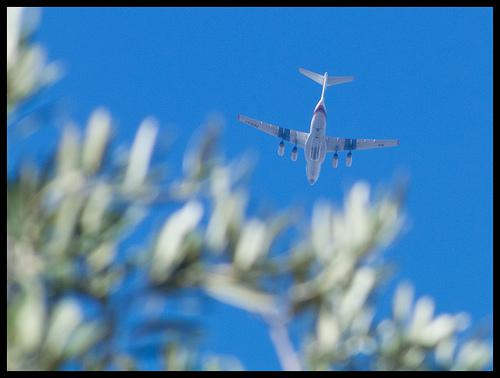Question: what is blurry?
Choices:
A. Berries.
B. Bushes.
C. Flowers.
D. Trees.
Answer with the letter. Answer: D Question: where is the plane?
Choices:
A. In the water.
B. In the sky.
C. In outer space.
D. On the ground.
Answer with the letter. Answer: B Question: how many clouds are in the sky?
Choices:
A. One.
B. Two.
C. None.
D. Three.
Answer with the letter. Answer: C 